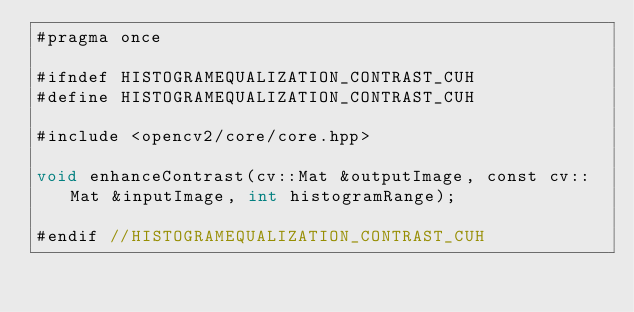Convert code to text. <code><loc_0><loc_0><loc_500><loc_500><_Cuda_>#pragma once

#ifndef HISTOGRAMEQUALIZATION_CONTRAST_CUH
#define HISTOGRAMEQUALIZATION_CONTRAST_CUH

#include <opencv2/core/core.hpp>

void enhanceContrast(cv::Mat &outputImage, const cv::Mat &inputImage, int histogramRange);

#endif //HISTOGRAMEQUALIZATION_CONTRAST_CUH</code> 